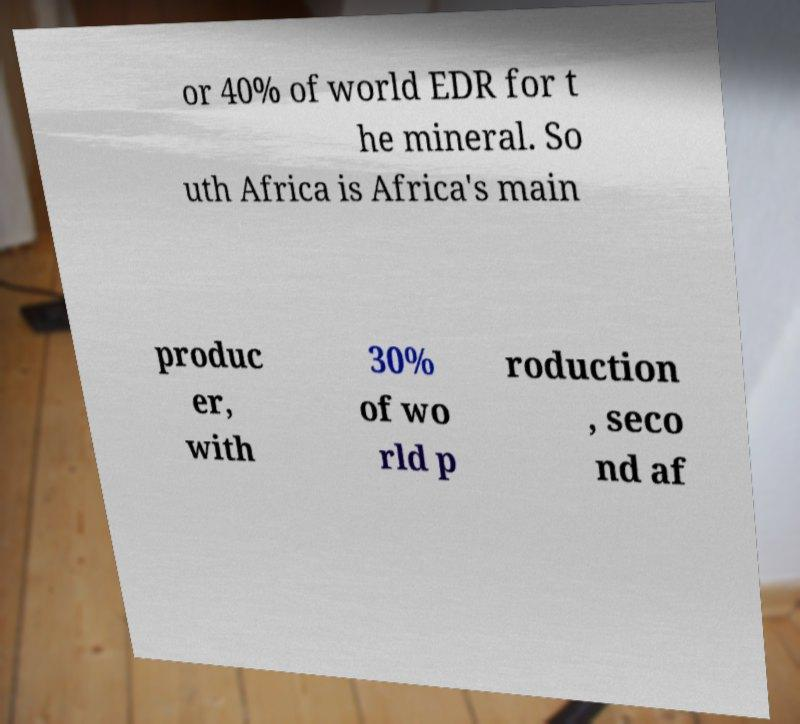Please read and relay the text visible in this image. What does it say? or 40% of world EDR for t he mineral. So uth Africa is Africa's main produc er, with 30% of wo rld p roduction , seco nd af 